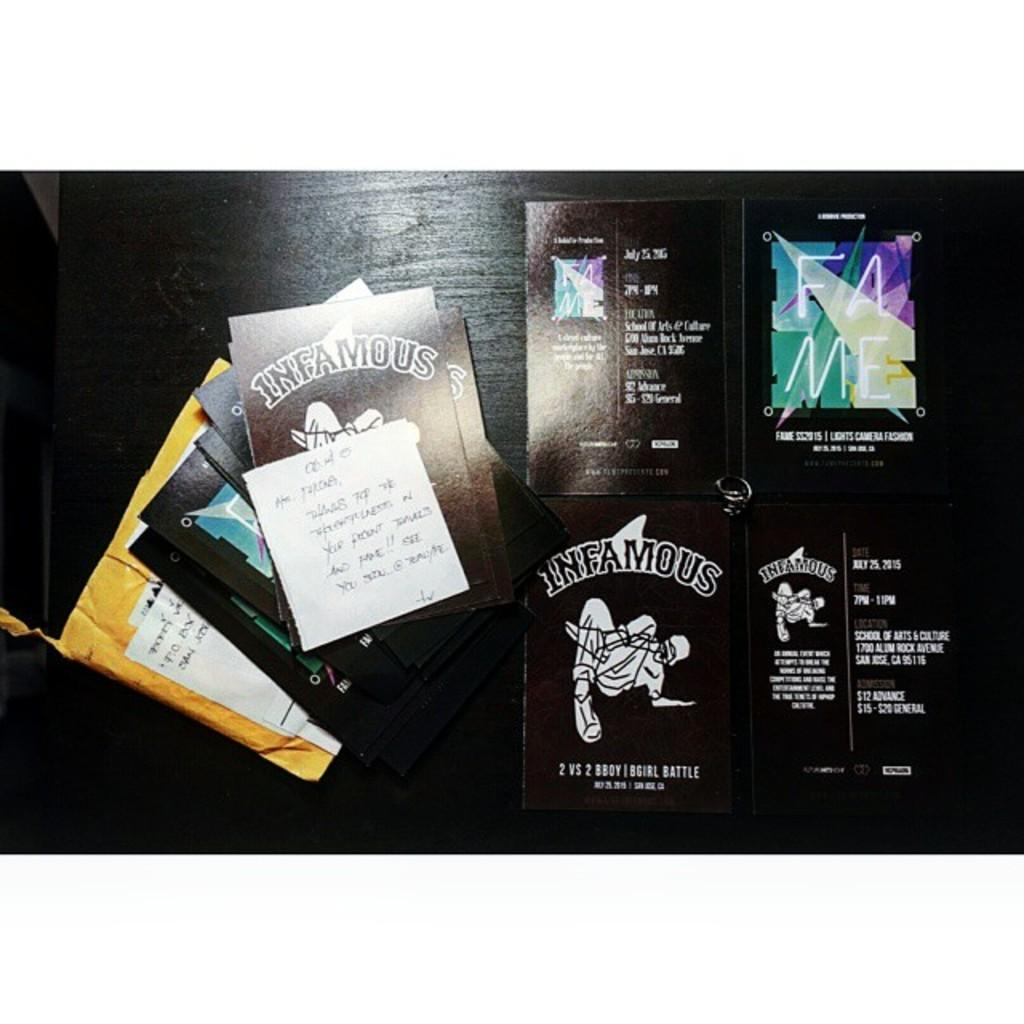<image>
Offer a succinct explanation of the picture presented. the word infamous is on a black background 